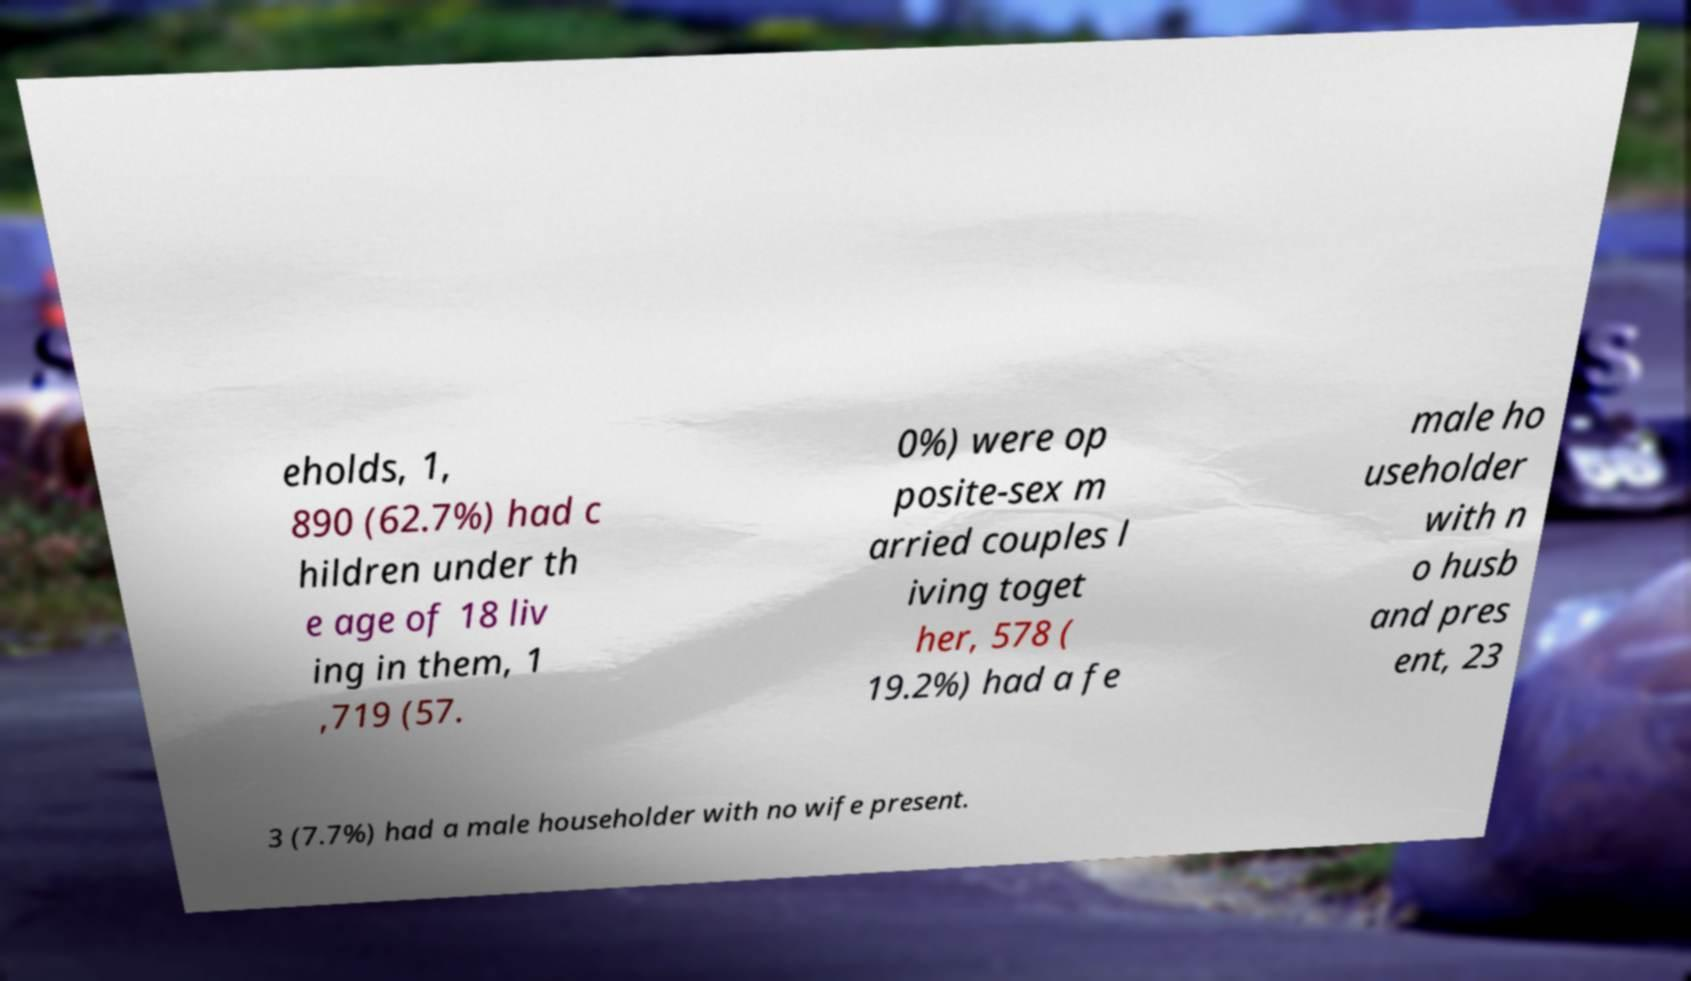There's text embedded in this image that I need extracted. Can you transcribe it verbatim? eholds, 1, 890 (62.7%) had c hildren under th e age of 18 liv ing in them, 1 ,719 (57. 0%) were op posite-sex m arried couples l iving toget her, 578 ( 19.2%) had a fe male ho useholder with n o husb and pres ent, 23 3 (7.7%) had a male householder with no wife present. 